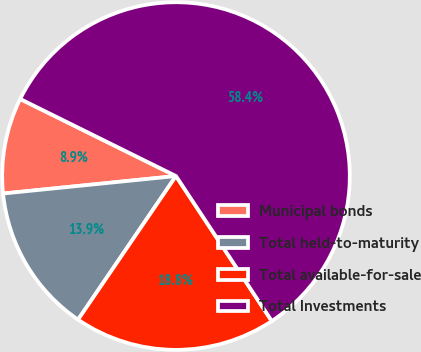<chart> <loc_0><loc_0><loc_500><loc_500><pie_chart><fcel>Municipal bonds<fcel>Total held-to-maturity<fcel>Total available-for-sale<fcel>Total Investments<nl><fcel>8.92%<fcel>13.87%<fcel>18.82%<fcel>58.4%<nl></chart> 